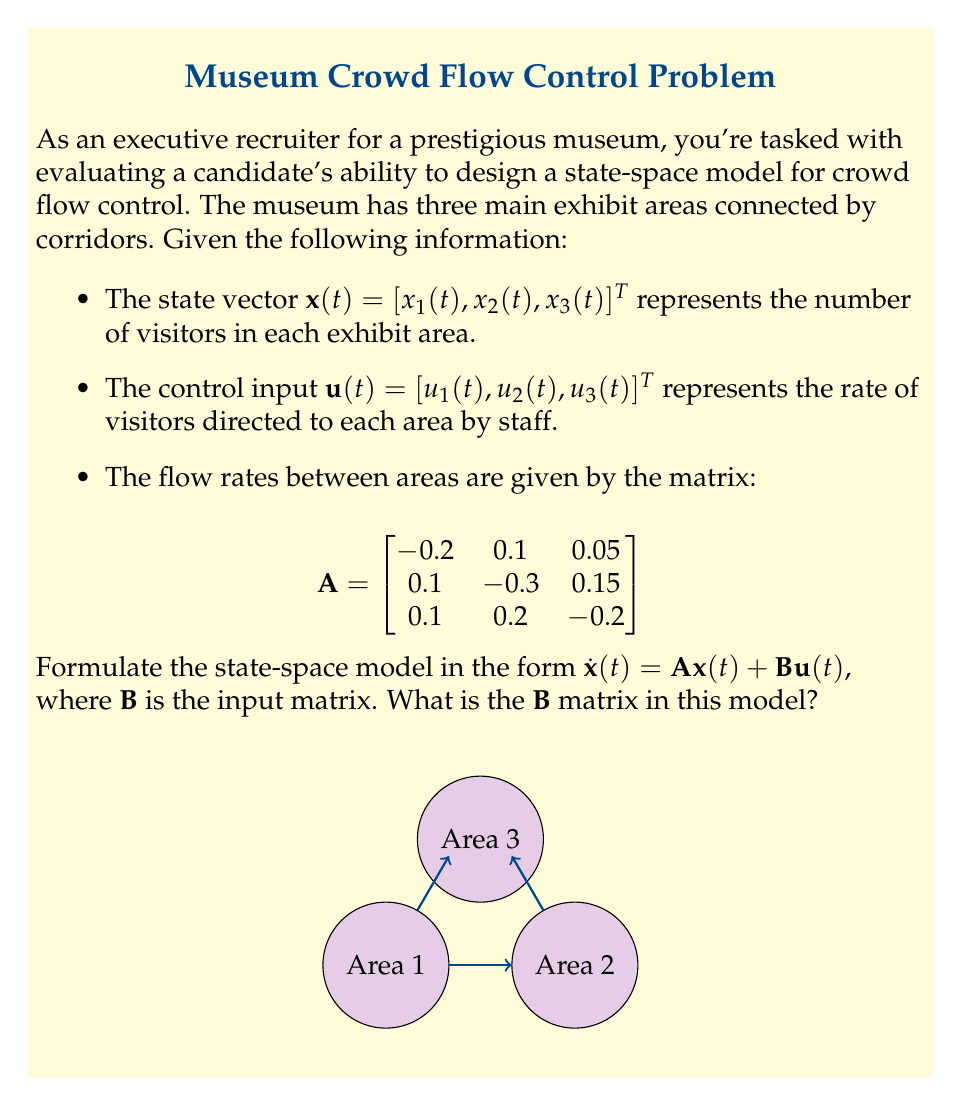Show me your answer to this math problem. To design the state-space model for crowd flow control in this museum setting, we need to understand the components of the model and how they relate to the given information.

1. The state-space model is given by the equation:
   $$\dot{x}(t) = Ax(t) + Bu(t)$$

2. We already have the $A$ matrix, which represents the flow rates between exhibit areas:
   $$A = \begin{bmatrix}
   -0.2 & 0.1 & 0.05 \\
   0.1 & -0.3 & 0.15 \\
   0.1 & 0.2 & -0.2
   \end{bmatrix}$$

3. The $B$ matrix represents how the control inputs affect the rate of change of the state variables. In this case, it shows how the staff's direction of visitors ($u(t)$) affects the number of visitors in each area ($x(t)$).

4. Since each control input $u_i(t)$ directly affects the corresponding state variable $x_i(t)$, and there's no cross-influence, the $B$ matrix will be a diagonal matrix.

5. The diagonal elements of $B$ should be 1, as each control input has a direct, one-to-one effect on the rate of change of visitors in the corresponding area.

6. Therefore, the $B$ matrix is:
   $$B = \begin{bmatrix}
   1 & 0 & 0 \\
   0 & 1 & 0 \\
   0 & 0 & 1
   \end{bmatrix}$$

This $B$ matrix ensures that each control input $u_i(t)$ directly influences the rate of change of visitors in the corresponding exhibit area $x_i(t)$, while the $A$ matrix accounts for the natural flow of visitors between areas.
Answer: $$B = \begin{bmatrix}
1 & 0 & 0 \\
0 & 1 & 0 \\
0 & 0 & 1
\end{bmatrix}$$ 